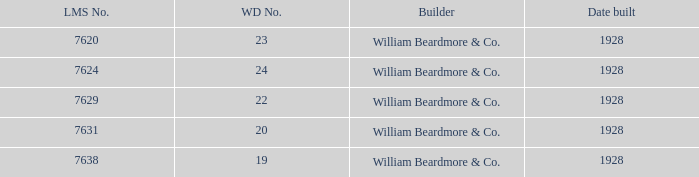Identify the lms figure for the serial number 37 7624.0. 